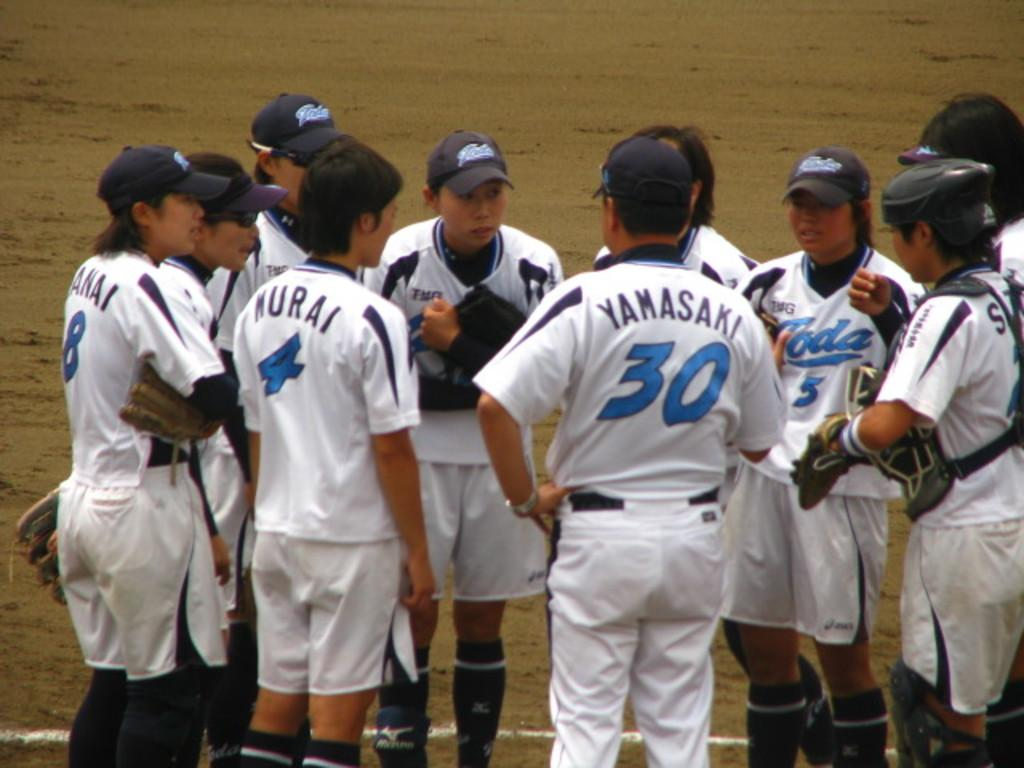<image>
Render a clear and concise summary of the photo. Baseball player wearing number 30 in a huddle with the team. 